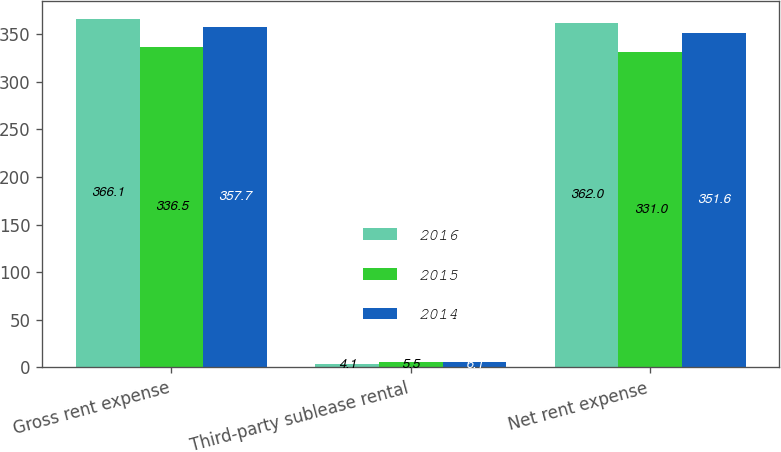<chart> <loc_0><loc_0><loc_500><loc_500><stacked_bar_chart><ecel><fcel>Gross rent expense<fcel>Third-party sublease rental<fcel>Net rent expense<nl><fcel>2016<fcel>366.1<fcel>4.1<fcel>362<nl><fcel>2015<fcel>336.5<fcel>5.5<fcel>331<nl><fcel>2014<fcel>357.7<fcel>6.1<fcel>351.6<nl></chart> 